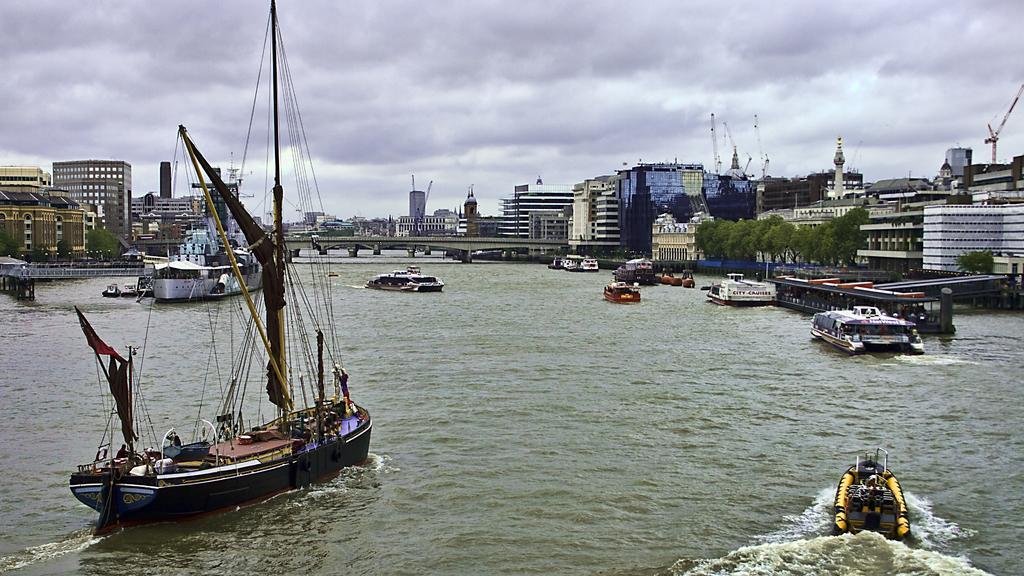Could you give a brief overview of what you see in this image? In this image, we can see boats are on the water. Background we can see buildings, bridges, pillars, trees, cranes and cloudy sky. 